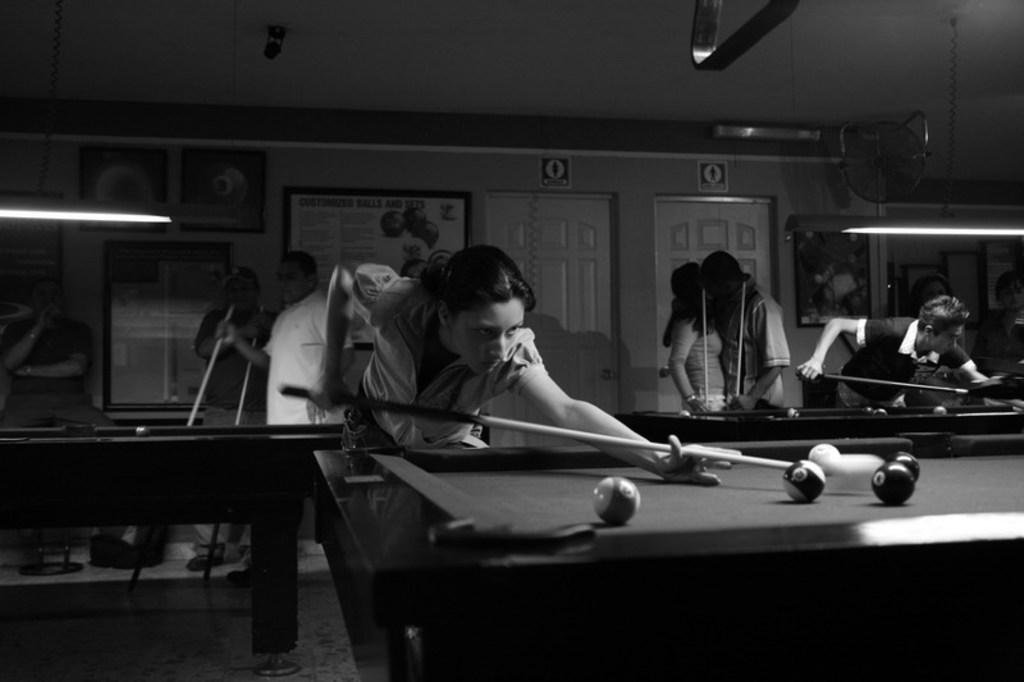Who or what can be seen in the image? There are people in the image. What activity might the people be engaged in? The presence of snooker tables in the image suggests that the people might be playing snooker or watching a game. What type of crime is being committed in the image? There is no indication of any crime being committed in the image; it features people and snooker tables. How does the twig contribute to the game of snooker in the image? There is no twig present in the image, so it cannot contribute to the game of snooker. 